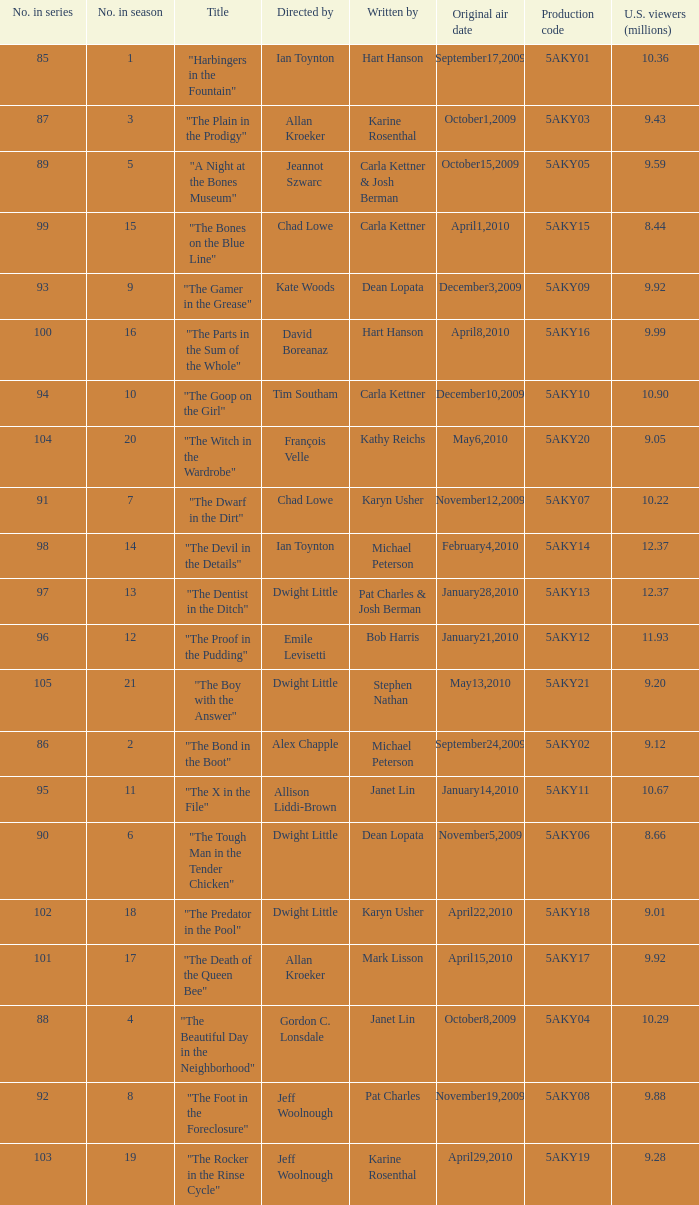Who was the writer of the episode with a production code of 5aky04? Janet Lin. 